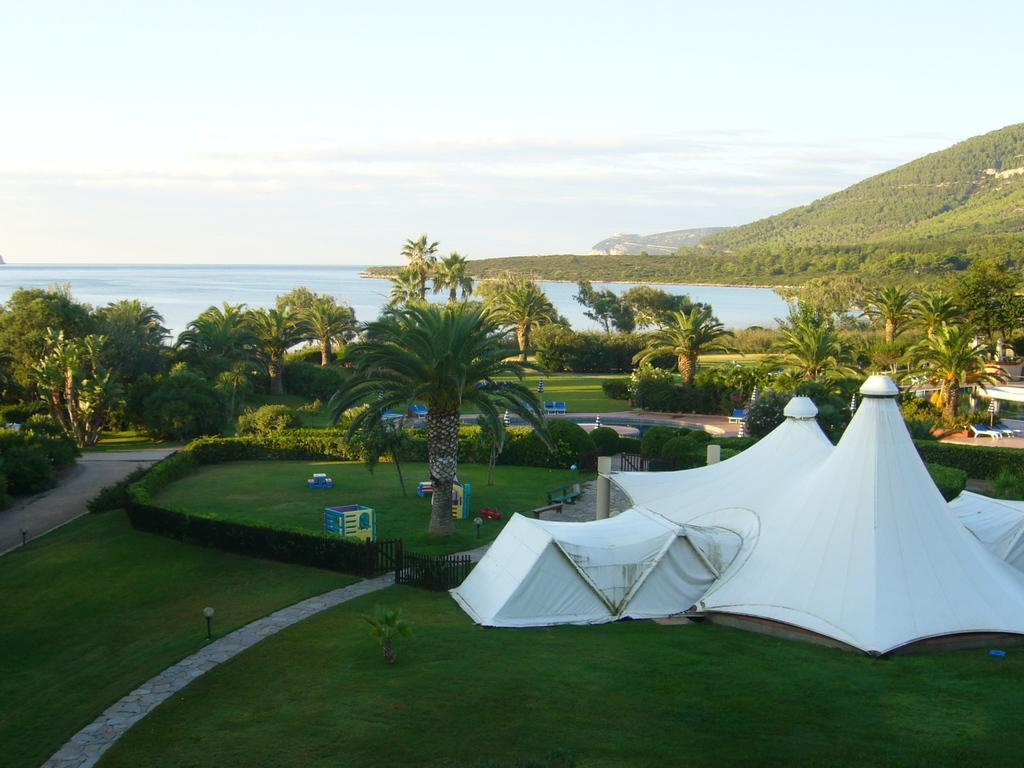What type of location is shown in the image? The image depicts a garden. What can be found in the garden? There are many plants and trees in the garden. Is there any structure or object in the garden? Yes, there is a tent on the right side of the garden. What can be seen in the background of the image? There is an ocean in the background of the image. What is visible at the top of the image? The sky is visible at the top of the image. What type of wrench is being used to protest in the garden? There is no wrench or protest present in the image; it depicts a garden with plants, trees, a tent, an ocean in the background, and the sky visible at the top. 